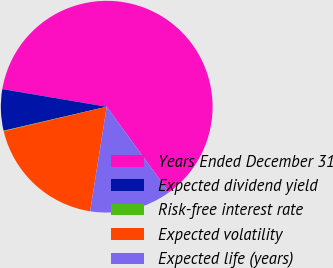<chart> <loc_0><loc_0><loc_500><loc_500><pie_chart><fcel>Years Ended December 31<fcel>Expected dividend yield<fcel>Risk-free interest rate<fcel>Expected volatility<fcel>Expected life (years)<nl><fcel>62.31%<fcel>6.31%<fcel>0.09%<fcel>18.76%<fcel>12.53%<nl></chart> 